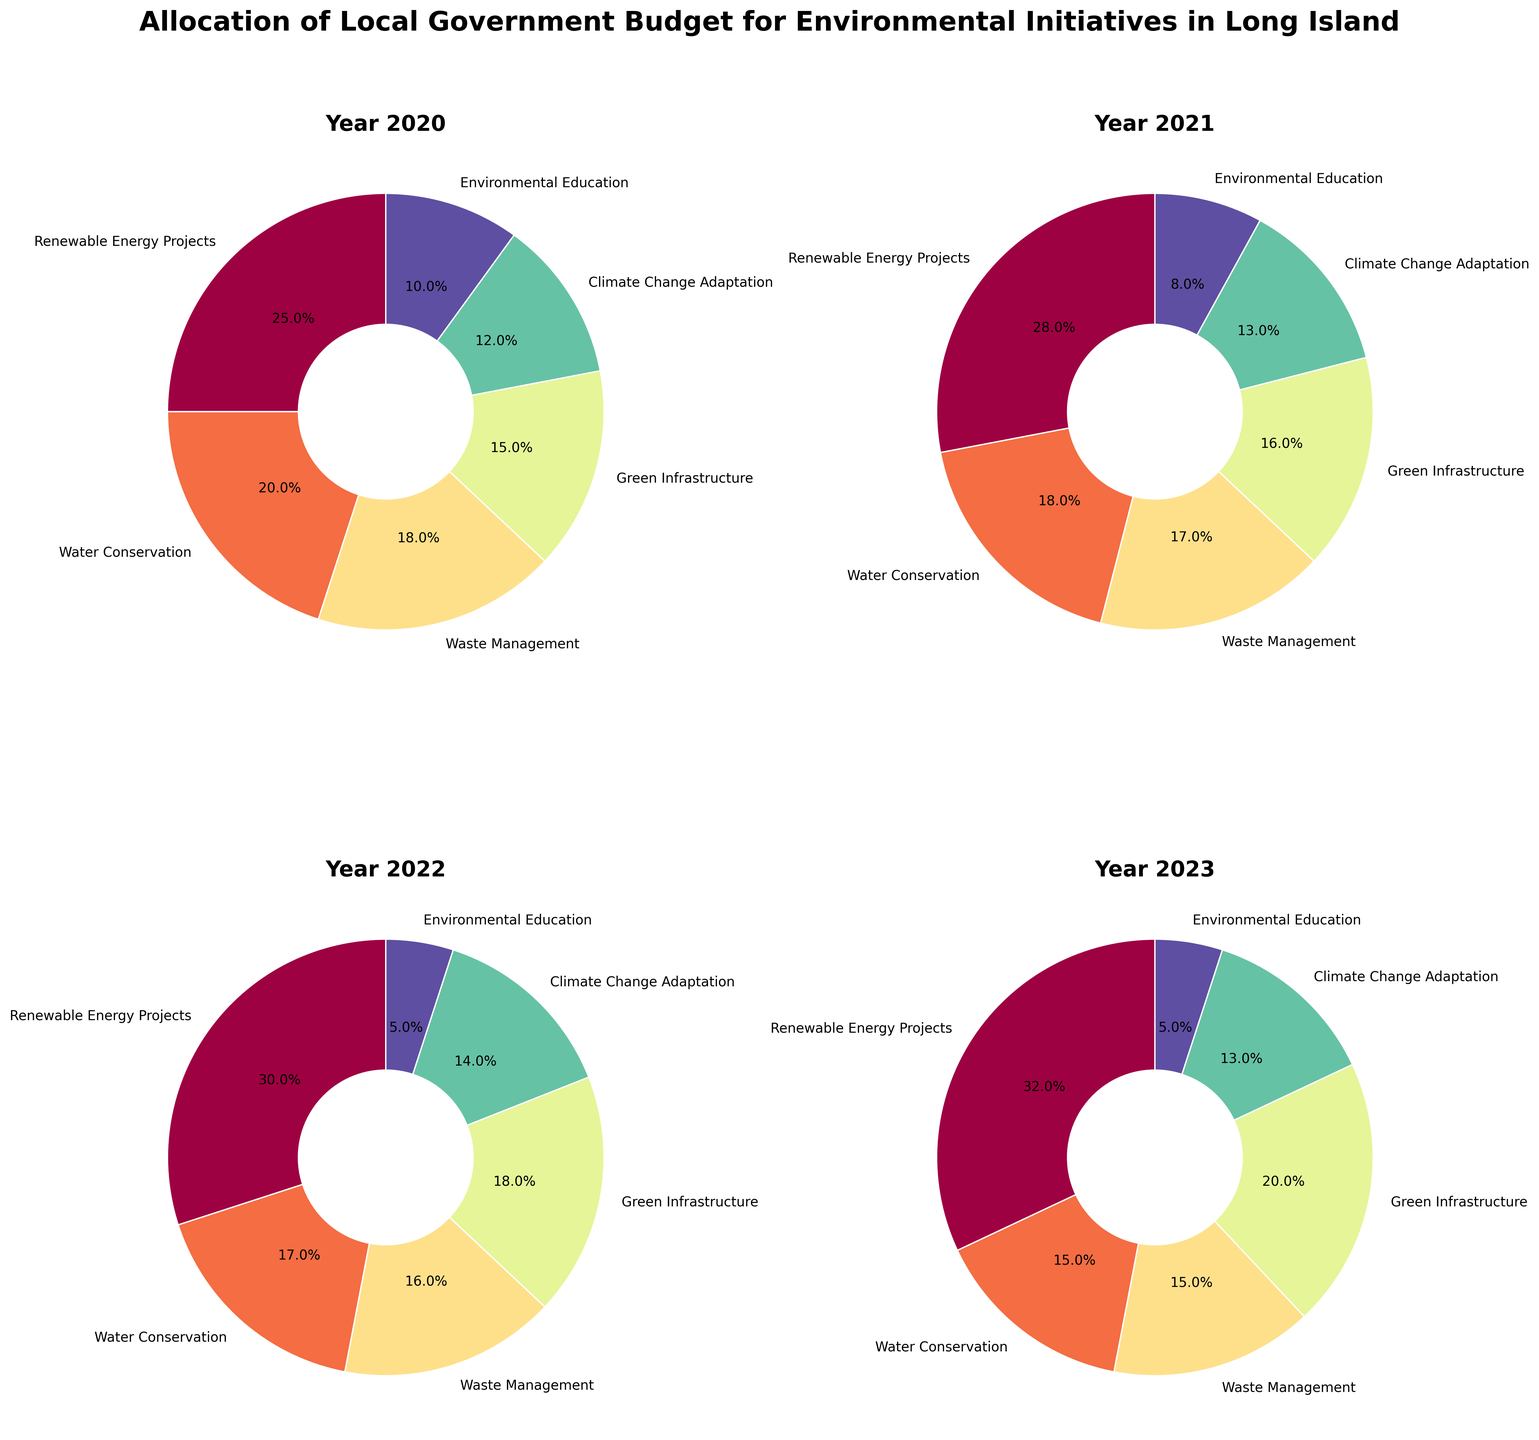Which category had the highest budget allocation in 2020? In the pie chart for the year 2020, the slice with the largest section represents "Renewable Energy Projects," showing that it had the highest budget allocation of 25%.
Answer: Renewable Energy Projects What percentage of the budget was allocated to 'Climate Change Adaptation' in 2023? In the pie chart for the year 2023, check the segment labeled "Climate Change Adaptation." It shows a budget allocation of 13%.
Answer: 13% How did the budget allocation for 'Environmental Education' change from 2020 to 2023? In the pie chart for the years 2020 and 2023, look at the segments for "Environmental Education." It went from 10% in 2020 down to 5% in 2023. The change is a decrease of 5 percentage points.
Answer: Decreased by 5 percentage points What is the total percentage allocated to 'Green Infrastructure' over all the years combined? Sum the percentages allocated to "Green Infrastructure" from each year: 15% (2020) + 16% (2021) + 18% (2022) + 20% (2023). The total percentage is 15% + 16% + 18% + 20% = 69%.
Answer: 69% Which category showed the most consistent budget allocation across the years? Compare the segments for each category across all the years. 'Climate Change Adaptation' has fairly consistent values: 12% (2020), 13% (2021), 14% (2022), and 13% (2023).
Answer: Climate Change Adaptation In which year did 'Renewable Energy Projects' witness the highest percentage increase compared to the previous year? Compare the percentages for 'Renewable Energy Projects' from year to year: 25% (2020), 28% (2021), 30% (2022), and 32% (2023). The highest percentage increase is from 2020 to 2021, which is 28% - 25% = 3% increase.
Answer: From 2020 to 2021 What was the budget percentage difference between 'Water Conservation' and 'Waste Management' in 2021? Look at the pie chart for 2021. 'Water Conservation' was allocated 18%, and 'Waste Management' was allocated 17%. The difference is 18% - 17% = 1%.
Answer: 1% What percentage of the budget was allocated to non-renewable energy projects in 2023? Subtract the percentage given to 'Renewable Energy Projects' from 100% in 2023. 'Renewable Energy Projects' had 32%, so 100% - 32% = 68%.
Answer: 68% Which category had the largest budget allocation increase in 2023 compared to 2022? Compare the percentages for each category between 2022 and 2023. 'Green Infrastructure' increased from 18% (2022) to 20% (2023), making it the largest increase of 2 percentage points.
Answer: Green Infrastructure 